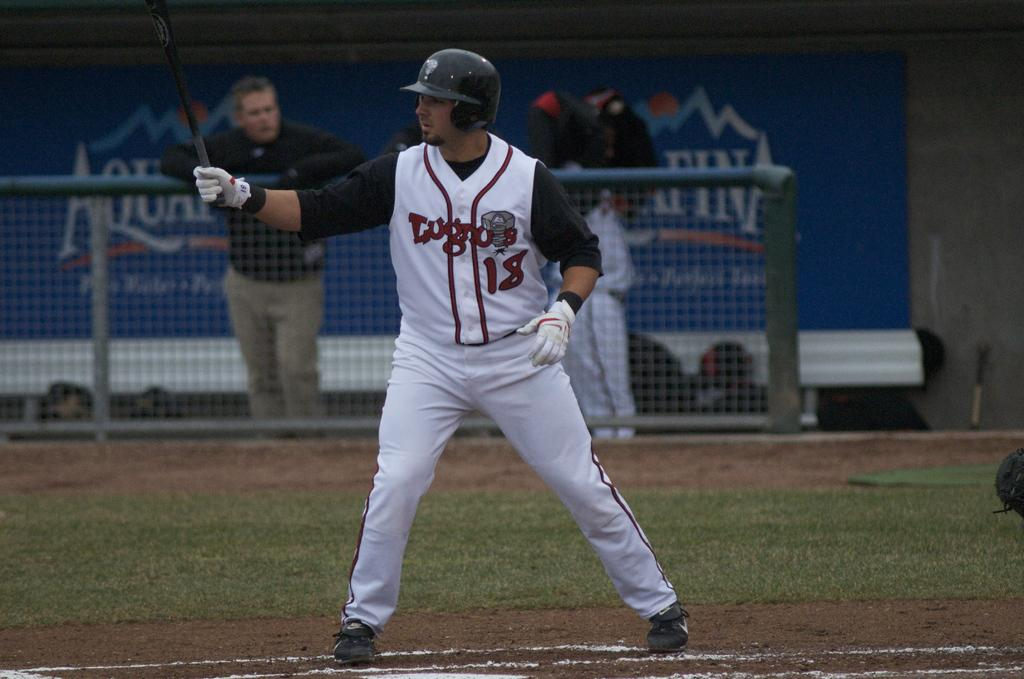Provide a one-sentence caption for the provided image. A baseball player is getting ready to bat wearing a jersey with the number 18 on it and while a man leaning on a fence watches. 